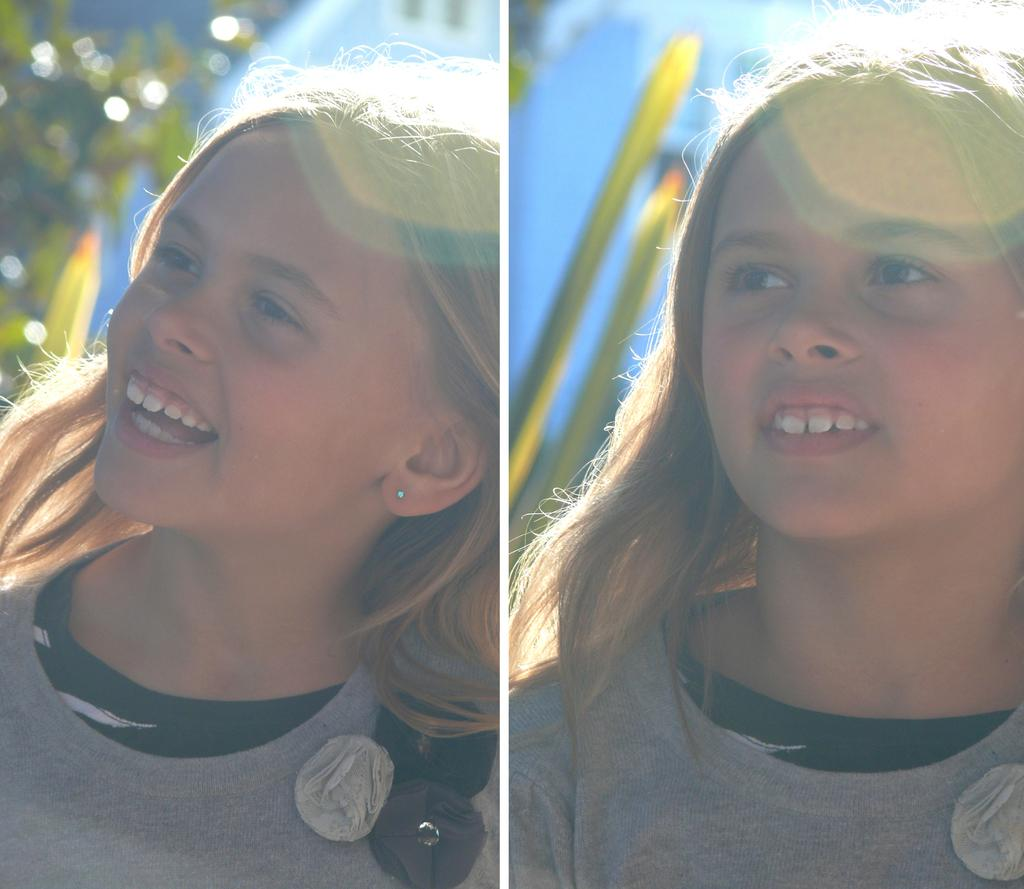What type of image is being described? The image is a collage. Can you identify any specific subjects or objects in the collage? Yes, there is a girl in the image. What type of glue is being used to hold the collage together in the image? There is no information provided about the use of glue or any other adhesive in the image. Can you tell me what the girl's role is as a judge in the image? There is no mention of the girl being a judge or having any specific role in the image. How does the girl's stomach appear in the image? There is no information provided about the girl's stomach or any other body part in the image. 